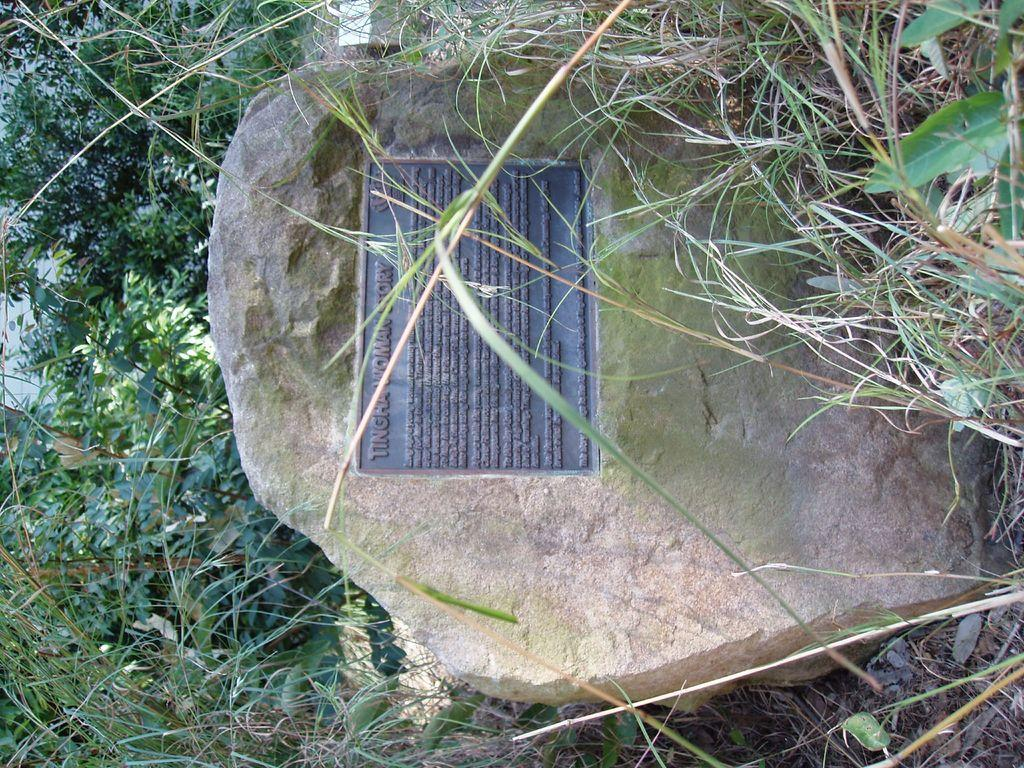What is on the board that is visible in the image? There is text on the board in the image. Where is the board located in the image? The board is placed on a rock in the image. What can be seen in the background of the image? There is a group of trees and grass visible in the background of the image. What object is placed on the ground in the background of the image? There is an object placed on the ground in the background of the image, but its specific details are not mentioned in the provided facts. How many pigs are visible in the image? There are no pigs visible in the image. 